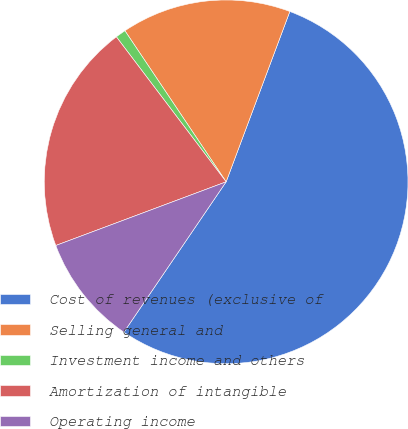<chart> <loc_0><loc_0><loc_500><loc_500><pie_chart><fcel>Cost of revenues (exclusive of<fcel>Selling general and<fcel>Investment income and others<fcel>Amortization of intangible<fcel>Operating income<nl><fcel>53.81%<fcel>15.09%<fcel>0.92%<fcel>20.38%<fcel>9.8%<nl></chart> 